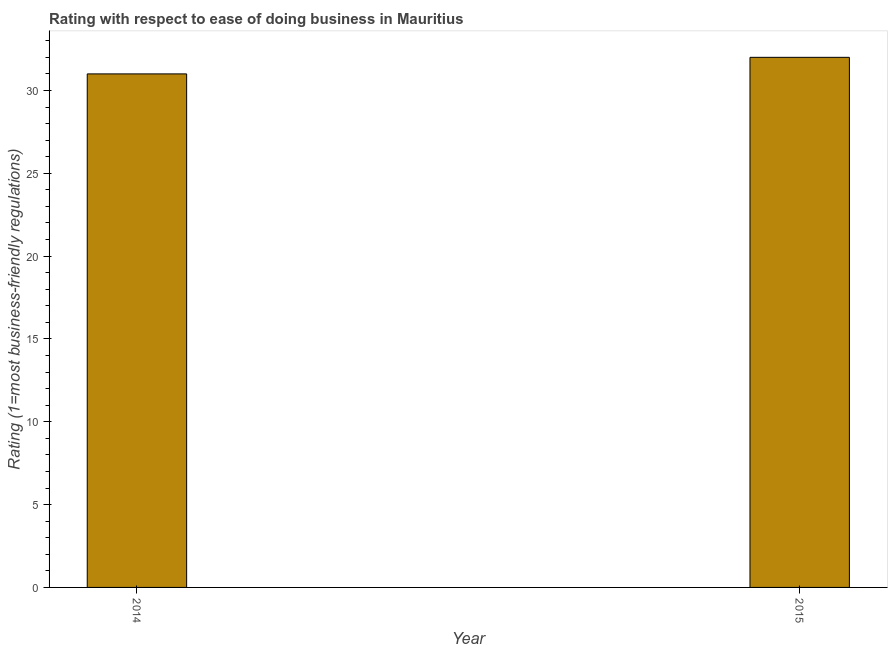Does the graph contain any zero values?
Provide a succinct answer. No. Does the graph contain grids?
Give a very brief answer. No. What is the title of the graph?
Offer a terse response. Rating with respect to ease of doing business in Mauritius. What is the label or title of the X-axis?
Your response must be concise. Year. What is the label or title of the Y-axis?
Provide a succinct answer. Rating (1=most business-friendly regulations). What is the ease of doing business index in 2015?
Offer a very short reply. 32. Across all years, what is the maximum ease of doing business index?
Offer a very short reply. 32. Across all years, what is the minimum ease of doing business index?
Keep it short and to the point. 31. In which year was the ease of doing business index maximum?
Keep it short and to the point. 2015. What is the median ease of doing business index?
Make the answer very short. 31.5. Do a majority of the years between 2015 and 2014 (inclusive) have ease of doing business index greater than 15 ?
Offer a terse response. No. Is the ease of doing business index in 2014 less than that in 2015?
Make the answer very short. Yes. How many bars are there?
Provide a succinct answer. 2. What is the difference between two consecutive major ticks on the Y-axis?
Offer a terse response. 5. Are the values on the major ticks of Y-axis written in scientific E-notation?
Provide a succinct answer. No. 